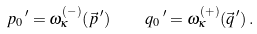<formula> <loc_0><loc_0><loc_500><loc_500>p _ { 0 } \, ^ { \prime } = \omega ^ { ( - ) } _ { \kappa } ( \vec { p } \, ^ { \prime } ) \quad q _ { 0 } \, ^ { \prime } = \omega ^ { ( + ) } _ { \kappa } ( \vec { q } \, ^ { \prime } ) \, .</formula> 